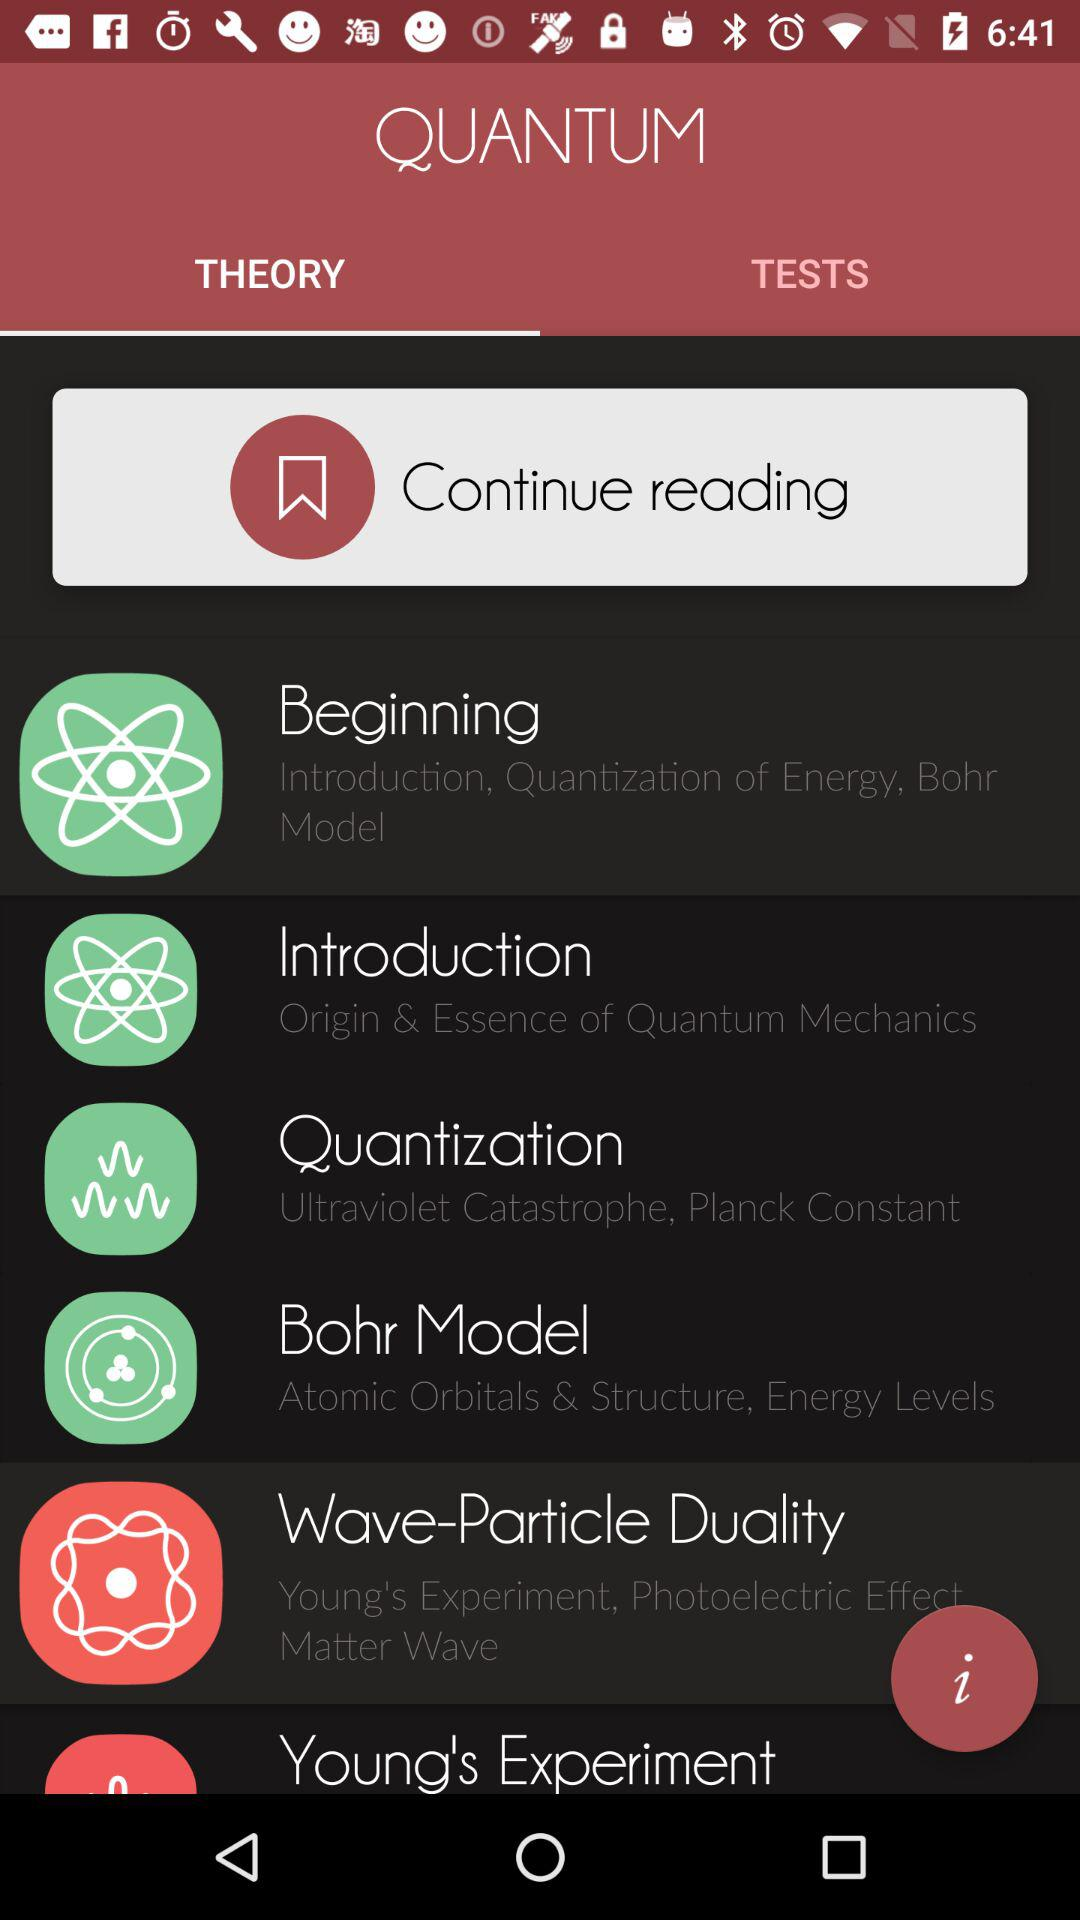What is the name of the application? The name of the application is "QUANTUM". 